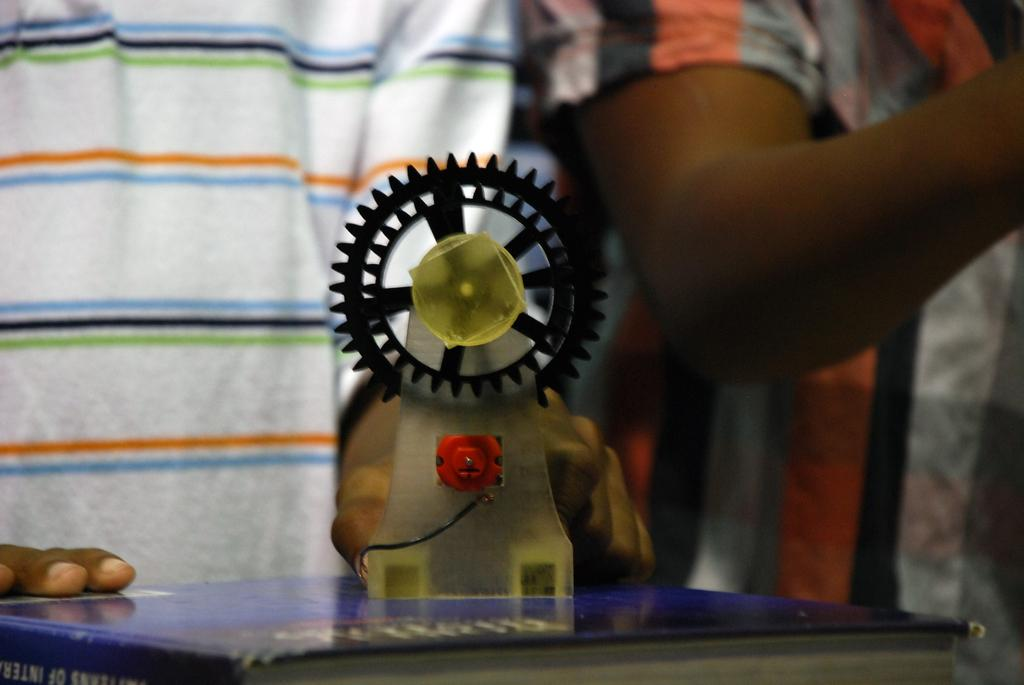What is the main object in the image? There is a book in the image. Can you describe any other objects in the image? There is an object in the image, but its specific nature is not mentioned. Are there any people visible in the image? Yes, there are two persons in the background of the image, but they are truncated. How much gold can be seen in the image? There is no gold present in the image. What type of quicksand is visible in the image? There is no quicksand present in the image. 